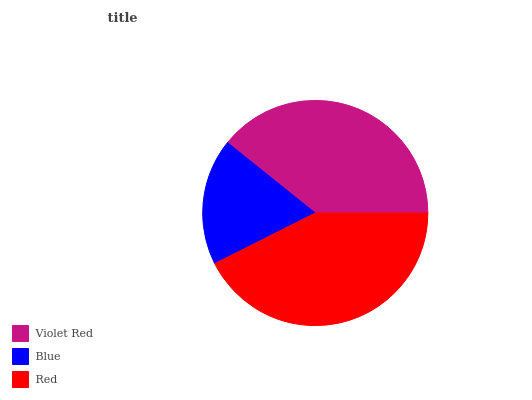Is Blue the minimum?
Answer yes or no. Yes. Is Red the maximum?
Answer yes or no. Yes. Is Red the minimum?
Answer yes or no. No. Is Blue the maximum?
Answer yes or no. No. Is Red greater than Blue?
Answer yes or no. Yes. Is Blue less than Red?
Answer yes or no. Yes. Is Blue greater than Red?
Answer yes or no. No. Is Red less than Blue?
Answer yes or no. No. Is Violet Red the high median?
Answer yes or no. Yes. Is Violet Red the low median?
Answer yes or no. Yes. Is Blue the high median?
Answer yes or no. No. Is Blue the low median?
Answer yes or no. No. 